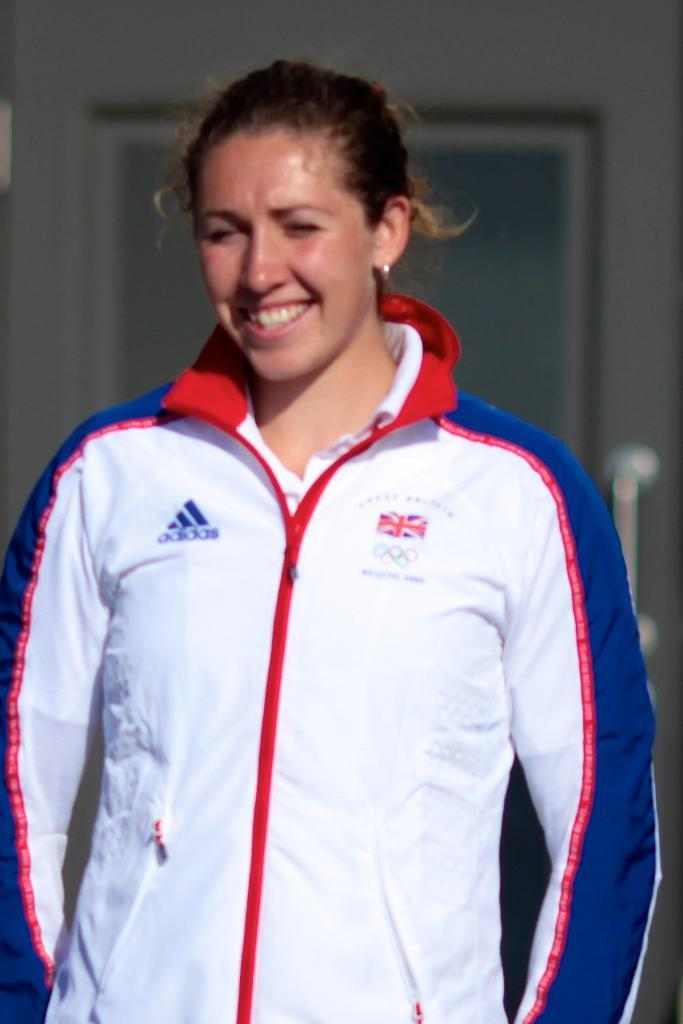Who is present in the image? There is a woman in the image. What is the woman doing in the image? The woman is standing in the image. What is the woman's facial expression in the image? The woman is smiling in the image. What type of pollution can be seen in the image? There is no pollution present in the image. What kind of shoes is the woman wearing in the image? The image does not show the woman's shoes, so it cannot be determined from the image. 